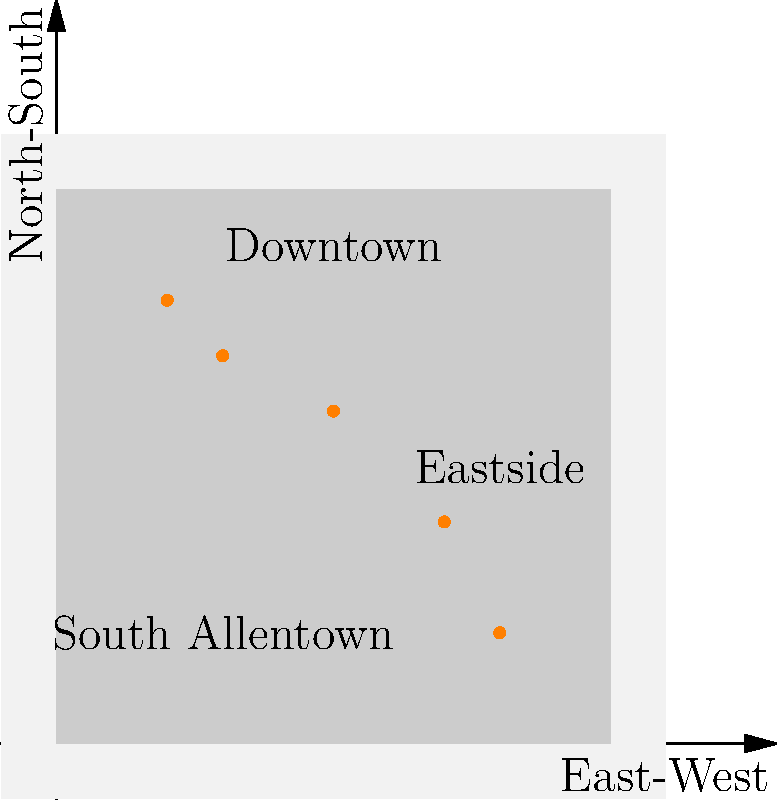Based on the map of Allentown showing the distribution of Latino-owned businesses, which neighborhood appears to have the highest concentration of these businesses? To determine which neighborhood has the highest concentration of Latino-owned businesses, we need to analyze the distribution of the orange dots on the map, which represent these businesses. Let's break it down step-by-step:

1. The map shows three labeled neighborhoods: Downtown, Eastside, and South Allentown.

2. We can see five orange dots representing Latino-owned businesses on the map.

3. Let's count the number of businesses in each neighborhood:
   - Downtown: 3 businesses (located in the upper-left quadrant)
   - Eastside: 1 business (located in the upper-right quadrant)
   - South Allentown: 1 business (located in the lower-left quadrant)

4. Comparing the counts:
   - Downtown has the highest number with 3 businesses
   - Both Eastside and South Allentown have 1 business each

5. Additionally, the businesses in Downtown appear to be closer together, indicating a higher concentration.

Based on this analysis, we can conclude that Downtown has the highest concentration of Latino-owned businesses among the neighborhoods shown on the map.
Answer: Downtown 